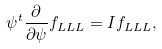Convert formula to latex. <formula><loc_0><loc_0><loc_500><loc_500>\psi ^ { t } \frac { \partial } { \partial \psi } f _ { L L L } = I f _ { L L L } ,</formula> 